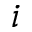Convert formula to latex. <formula><loc_0><loc_0><loc_500><loc_500>i</formula> 